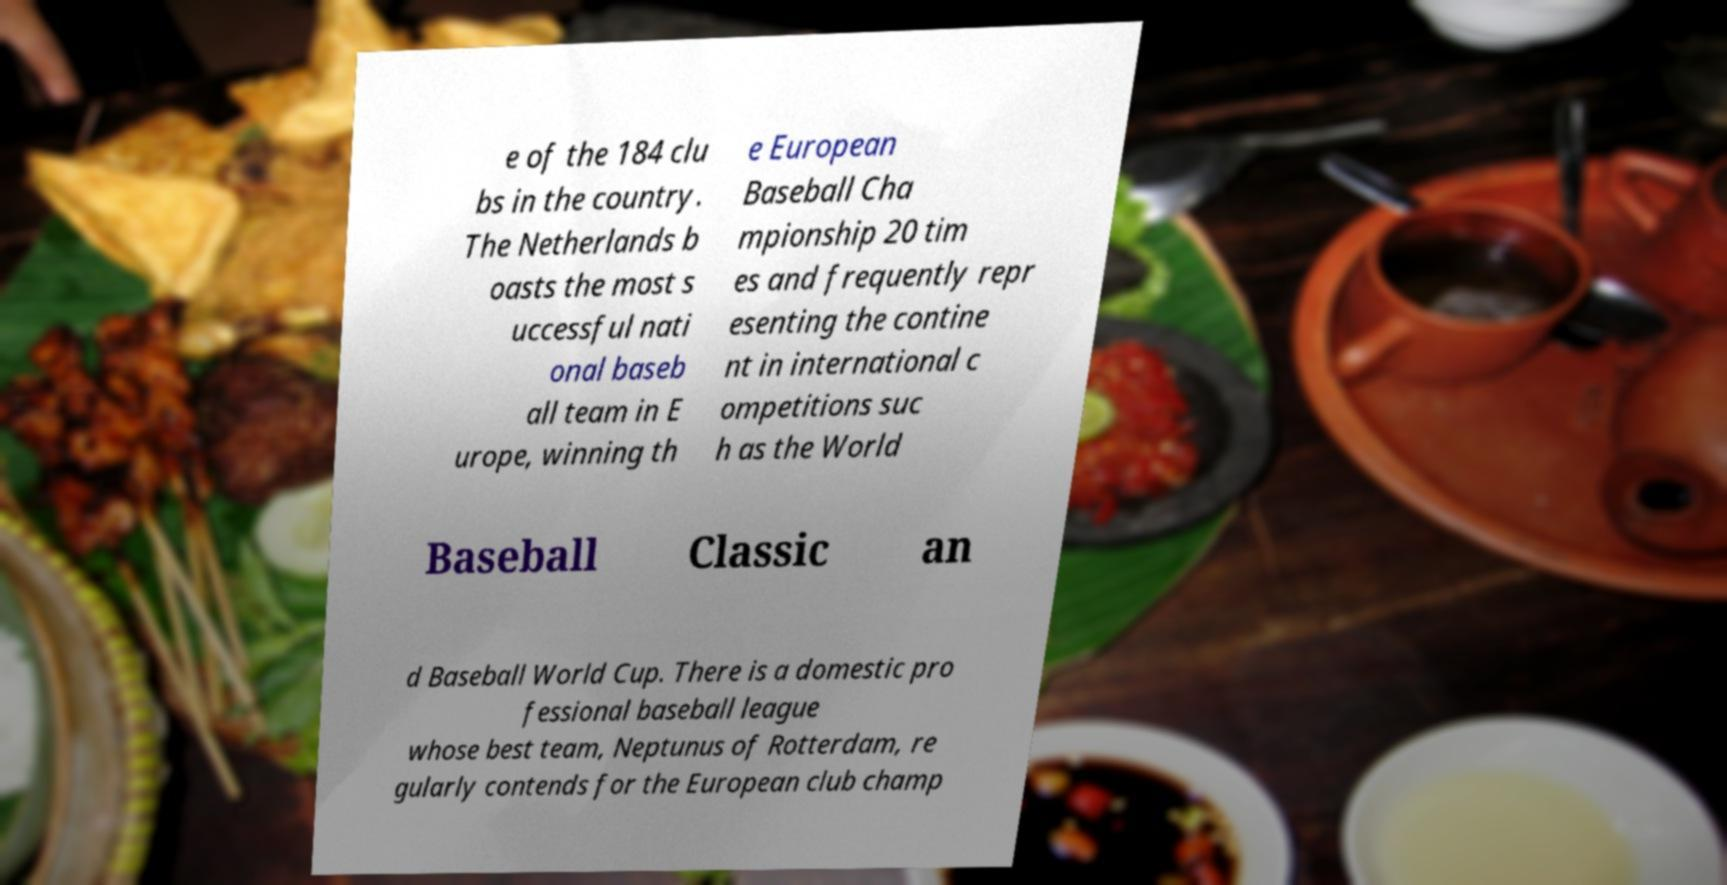Could you assist in decoding the text presented in this image and type it out clearly? e of the 184 clu bs in the country. The Netherlands b oasts the most s uccessful nati onal baseb all team in E urope, winning th e European Baseball Cha mpionship 20 tim es and frequently repr esenting the contine nt in international c ompetitions suc h as the World Baseball Classic an d Baseball World Cup. There is a domestic pro fessional baseball league whose best team, Neptunus of Rotterdam, re gularly contends for the European club champ 